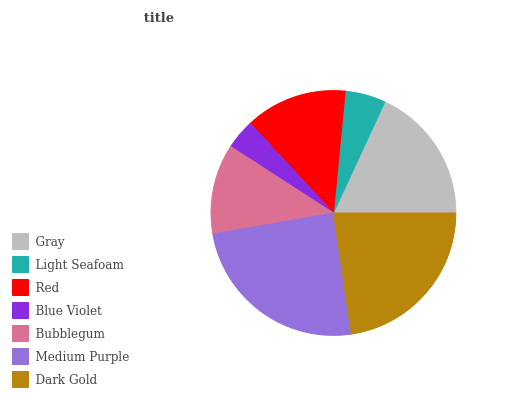Is Blue Violet the minimum?
Answer yes or no. Yes. Is Medium Purple the maximum?
Answer yes or no. Yes. Is Light Seafoam the minimum?
Answer yes or no. No. Is Light Seafoam the maximum?
Answer yes or no. No. Is Gray greater than Light Seafoam?
Answer yes or no. Yes. Is Light Seafoam less than Gray?
Answer yes or no. Yes. Is Light Seafoam greater than Gray?
Answer yes or no. No. Is Gray less than Light Seafoam?
Answer yes or no. No. Is Red the high median?
Answer yes or no. Yes. Is Red the low median?
Answer yes or no. Yes. Is Dark Gold the high median?
Answer yes or no. No. Is Blue Violet the low median?
Answer yes or no. No. 